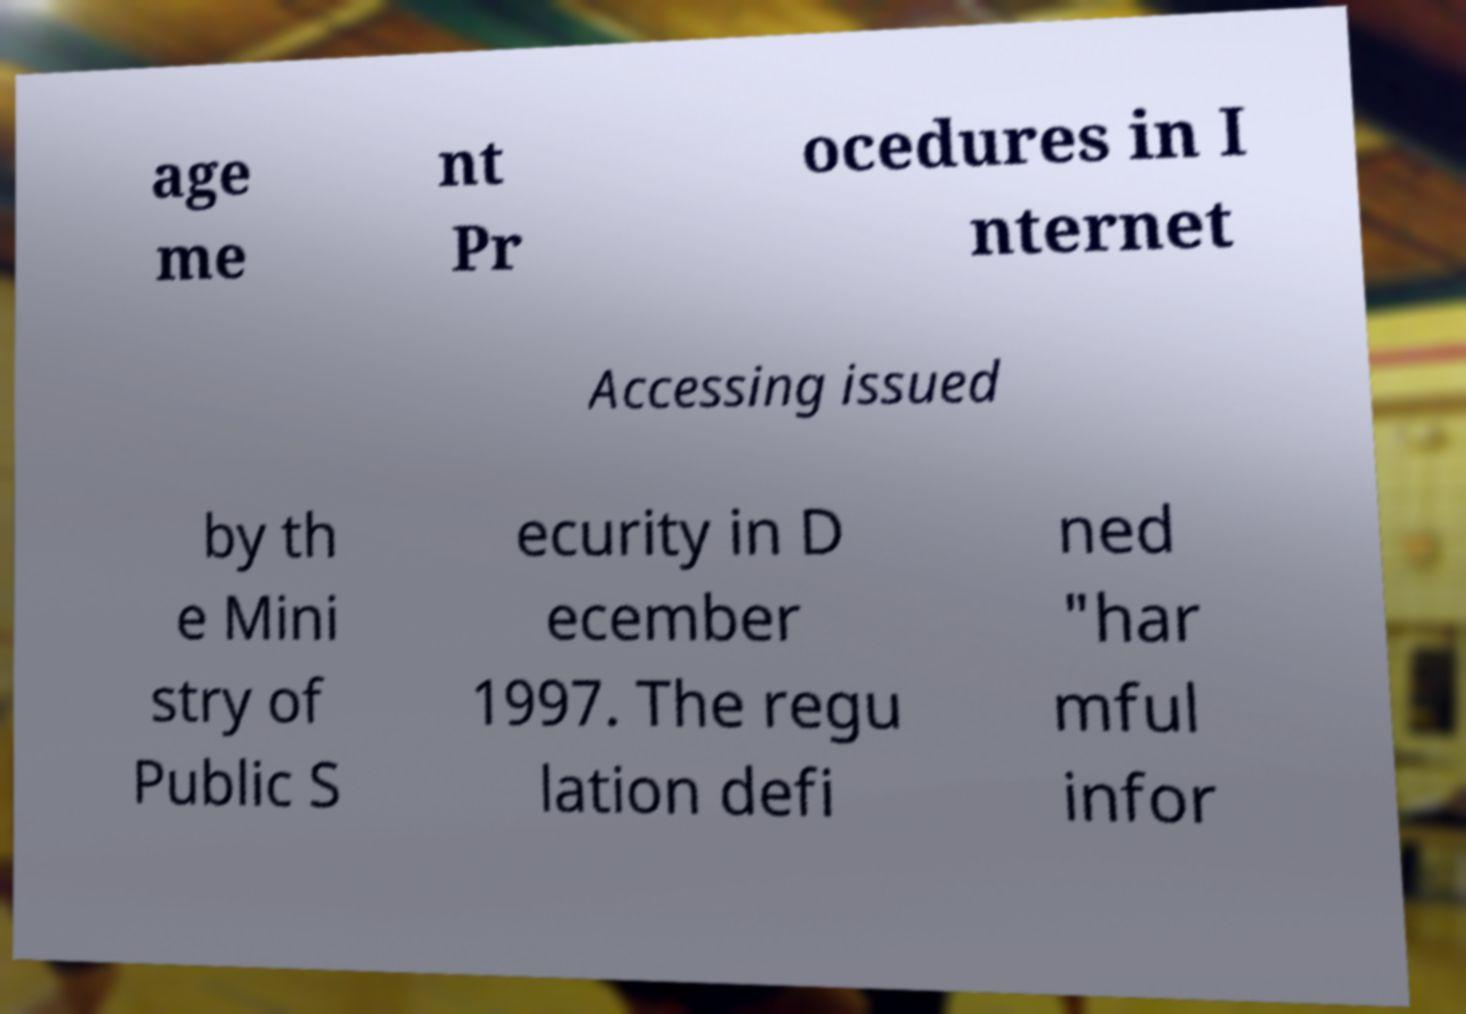Please read and relay the text visible in this image. What does it say? age me nt Pr ocedures in I nternet Accessing issued by th e Mini stry of Public S ecurity in D ecember 1997. The regu lation defi ned "har mful infor 